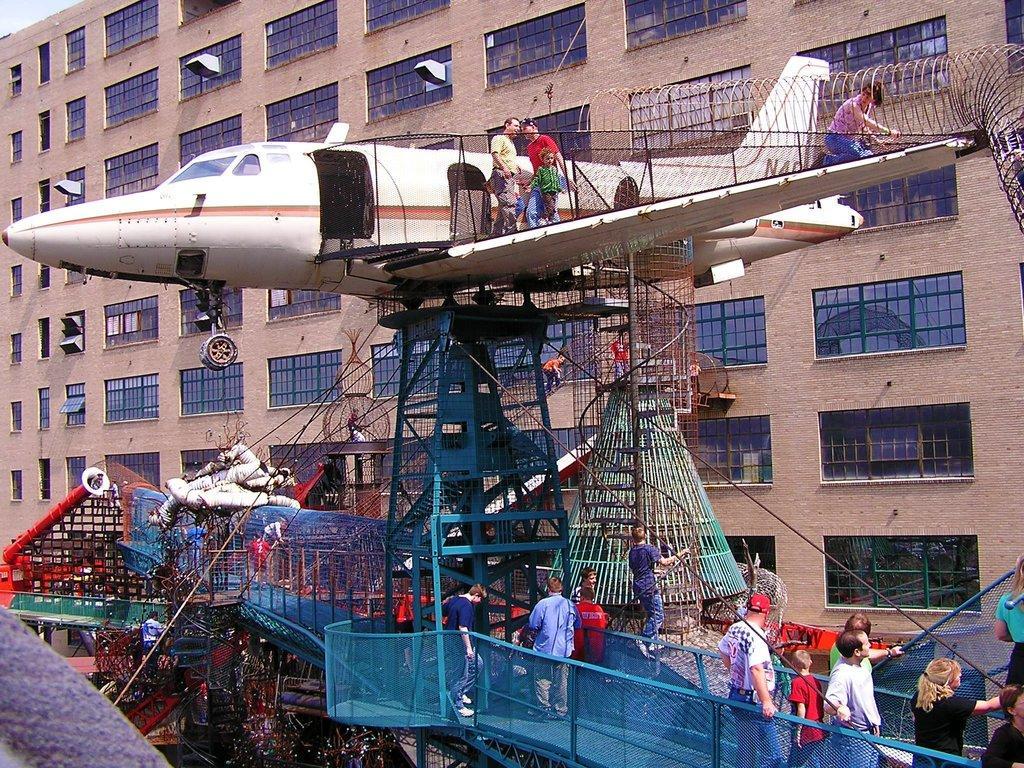Can you describe this image briefly? In this image we can see a building. There is an aircraft model in the image. There are a group of people are standing. 